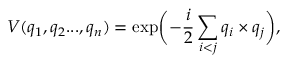Convert formula to latex. <formula><loc_0><loc_0><loc_500><loc_500>V ( q _ { 1 } , q _ { 2 } \dots , q _ { n } ) = \exp \left ( - \frac { i } { 2 } \sum _ { i < j } q _ { i } \times q _ { j } \right ) ,</formula> 